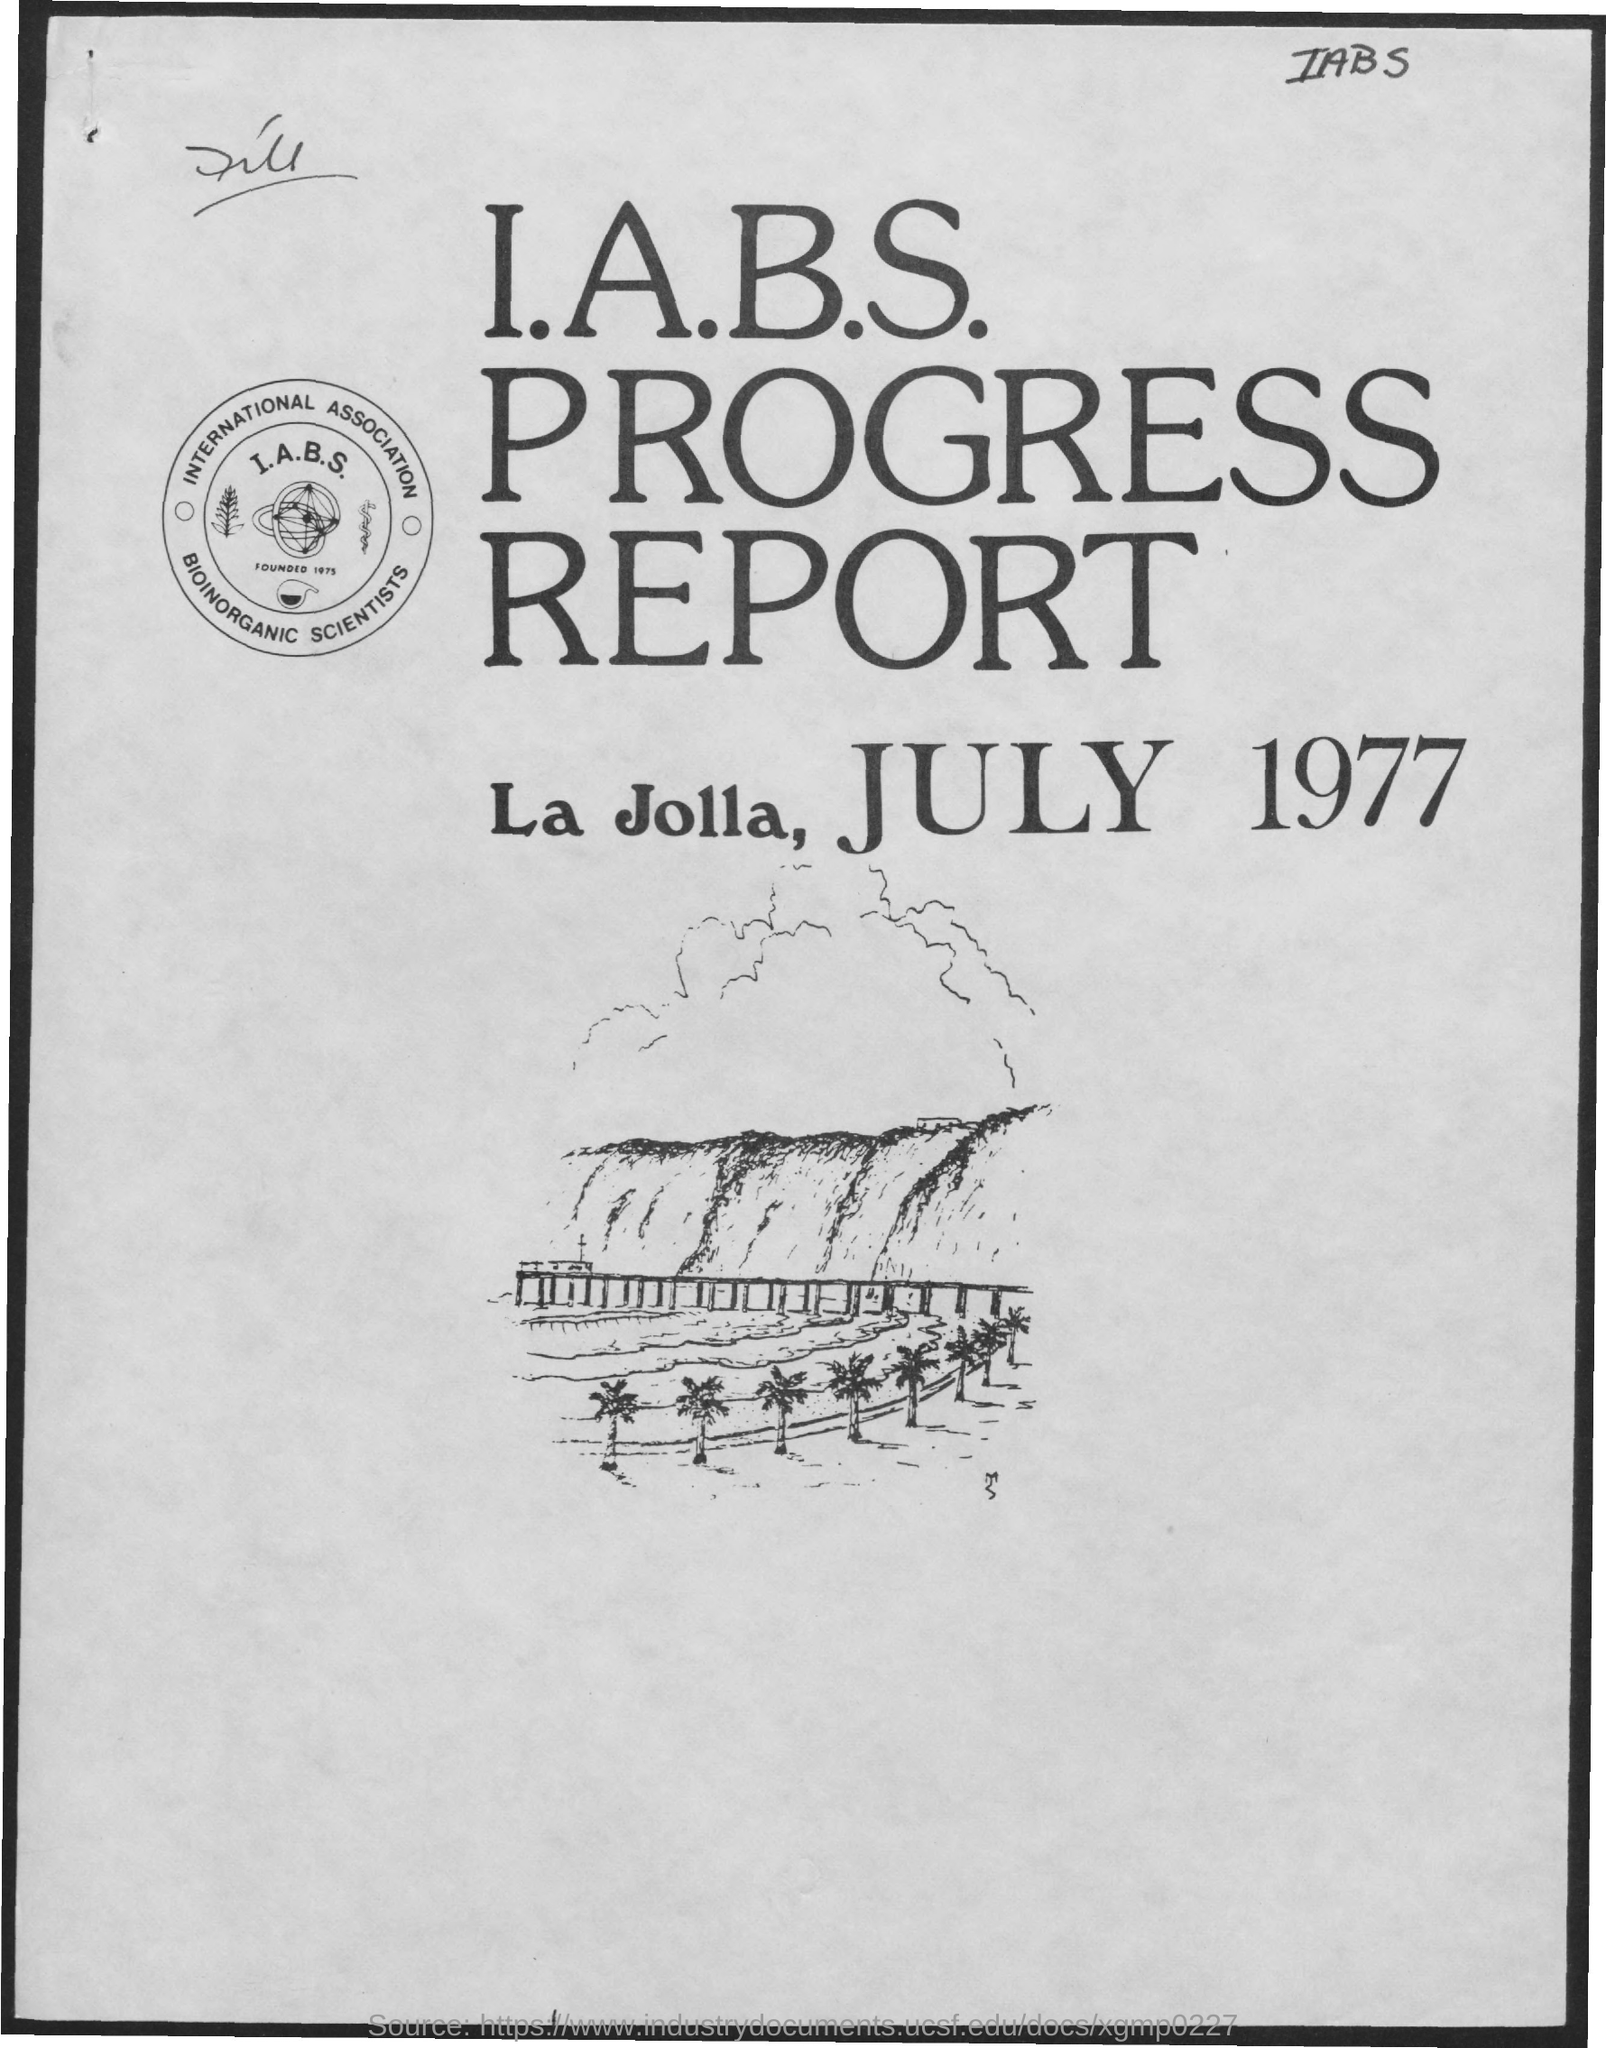Mention a couple of crucial points in this snapshot. The place of the report is La Jolla. July is mentioned in the page. The report was issued on July 1977. The name of the report is I.A.B.S. Progress Report. 